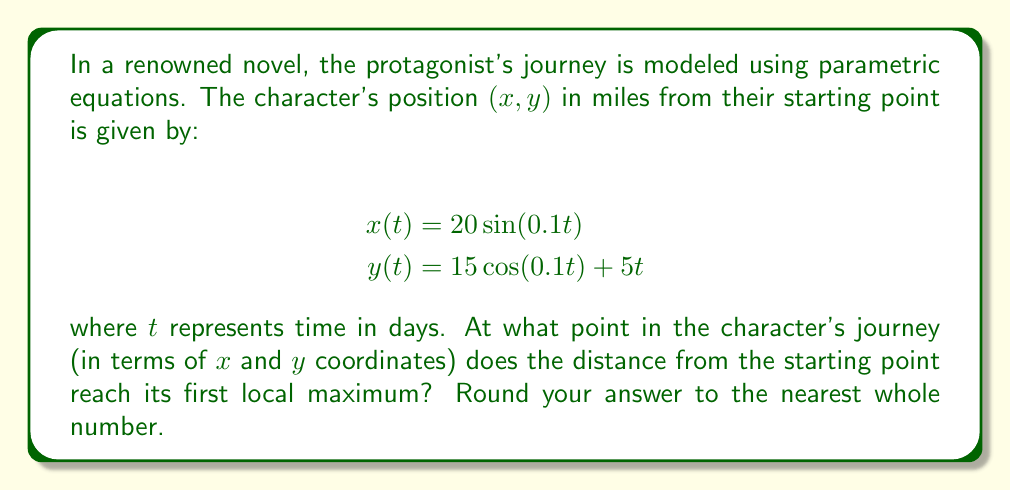Can you answer this question? To solve this problem, we need to follow these steps:

1) The distance from the starting point is given by:
   $$d(t) = \sqrt{x(t)^2 + y(t)^2}$$

2) Substitute the given equations:
   $$d(t) = \sqrt{(20\sin(0.1t))^2 + (15\cos(0.1t) + 5t)^2}$$

3) To find the local maximum, we need to find where the derivative of d(t) equals zero:
   $$\frac{d}{dt}d(t) = 0$$

4) This equation is complex to solve analytically, so we can use numerical methods or graphing to find the first local maximum.

5) Using a graphing calculator or computer software, we can plot d(t) and find that the first local maximum occurs at approximately t ≈ 31.4 days.

6) Plug this value back into the original parametric equations:
   $$x(31.4) = 20\sin(0.1 * 31.4) \approx 19.9$$
   $$y(31.4) = 15\cos(0.1 * 31.4) + 5 * 31.4 \approx 157.0$$

7) Rounding to the nearest whole number:
   x ≈ 20, y ≈ 157
Answer: (20, 157) 